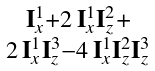<formula> <loc_0><loc_0><loc_500><loc_500>\begin{smallmatrix} \mathbf I _ { x } ^ { 1 } + 2 \, \mathbf I _ { x } ^ { 1 } \mathbf I _ { z } ^ { 2 } + \\ 2 \, \mathbf I _ { x } ^ { 1 } \mathbf I _ { z } ^ { 3 } - 4 \, \mathbf I _ { x } ^ { 1 } \mathbf I _ { z } ^ { 2 } \mathbf I _ { z } ^ { 3 } \end{smallmatrix}</formula> 